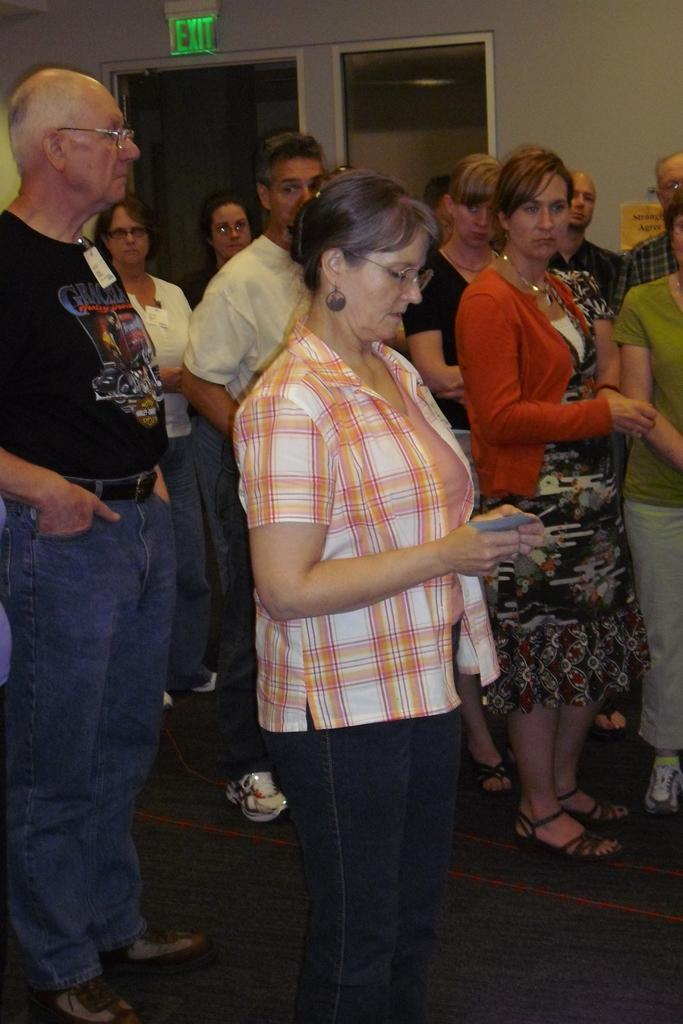How many people are in the group in the image? There is a group of people in the image, but the exact number is not specified. What are the people in the group doing? The people in the group are standing on the floor. Can you describe any specific features of the people in the group? Some people in the group are wearing spectacles. What can be seen in the background of the image? There is a wall, a name board, and a glass object in the background of the image. How many jellyfish are visible in the image? There are no jellyfish present in the image. What type of store can be seen in the background of the image? There is no store visible in the image; only a wall, a name board, and a glass object are present in the background. 